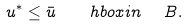<formula> <loc_0><loc_0><loc_500><loc_500>u ^ { * } \leq \bar { u } \quad h b o x { i n } \ \ B .</formula> 